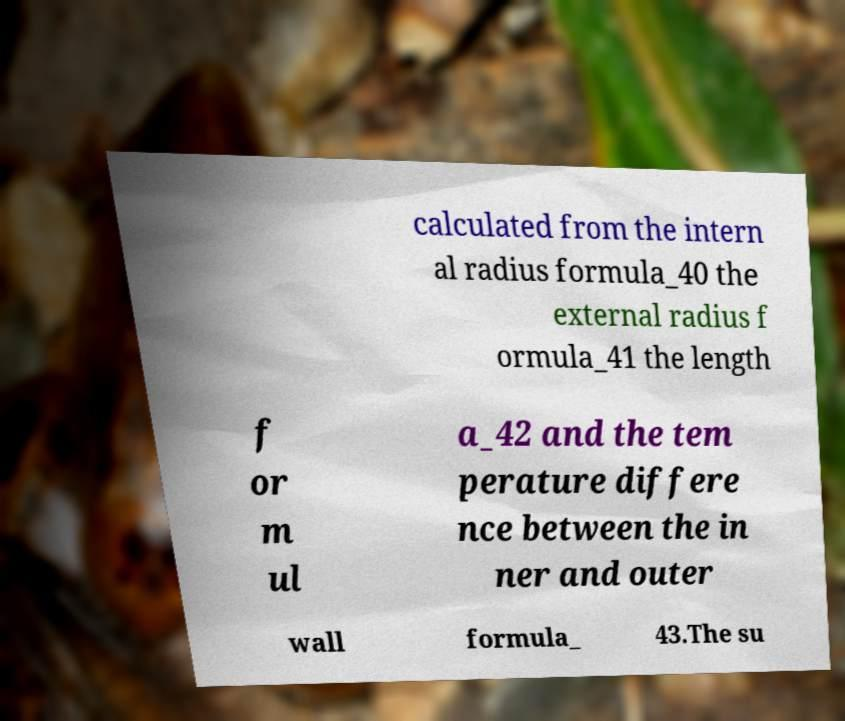Can you accurately transcribe the text from the provided image for me? calculated from the intern al radius formula_40 the external radius f ormula_41 the length f or m ul a_42 and the tem perature differe nce between the in ner and outer wall formula_ 43.The su 